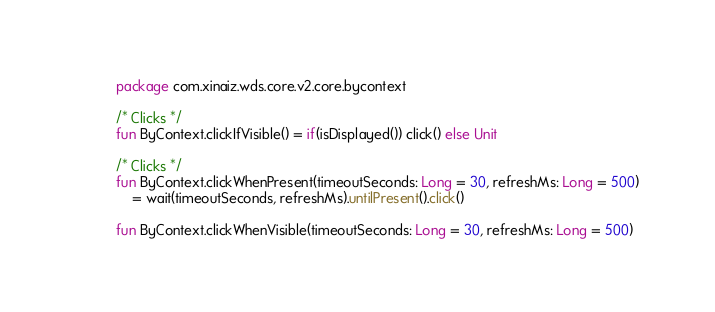<code> <loc_0><loc_0><loc_500><loc_500><_Kotlin_>package com.xinaiz.wds.core.v2.core.bycontext

/* Clicks */
fun ByContext.clickIfVisible() = if(isDisplayed()) click() else Unit

/* Clicks */
fun ByContext.clickWhenPresent(timeoutSeconds: Long = 30, refreshMs: Long = 500)
    = wait(timeoutSeconds, refreshMs).untilPresent().click()

fun ByContext.clickWhenVisible(timeoutSeconds: Long = 30, refreshMs: Long = 500)</code> 